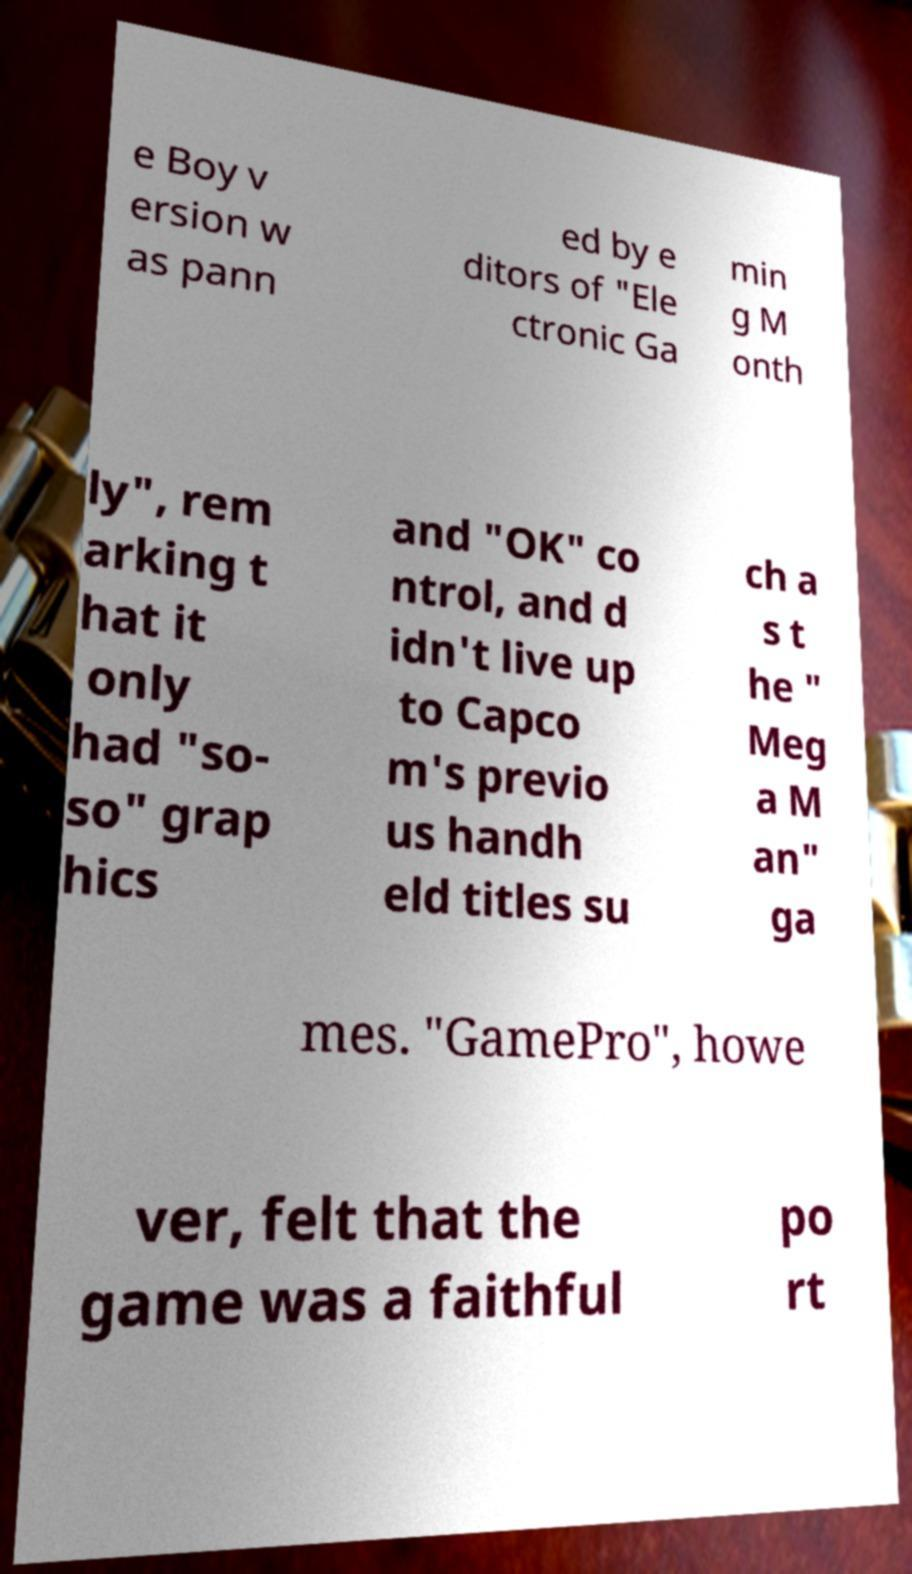Could you assist in decoding the text presented in this image and type it out clearly? e Boy v ersion w as pann ed by e ditors of "Ele ctronic Ga min g M onth ly", rem arking t hat it only had "so- so" grap hics and "OK" co ntrol, and d idn't live up to Capco m's previo us handh eld titles su ch a s t he " Meg a M an" ga mes. "GamePro", howe ver, felt that the game was a faithful po rt 